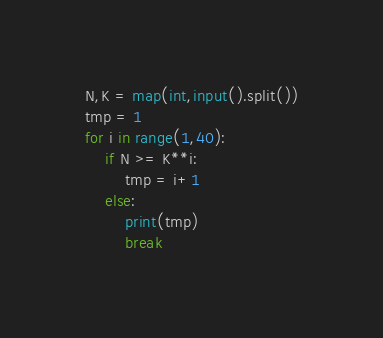<code> <loc_0><loc_0><loc_500><loc_500><_Python_>N,K = map(int,input().split())
tmp = 1
for i in range(1,40):
    if N >= K**i:
        tmp = i+1
    else:
        print(tmp)
        break
</code> 